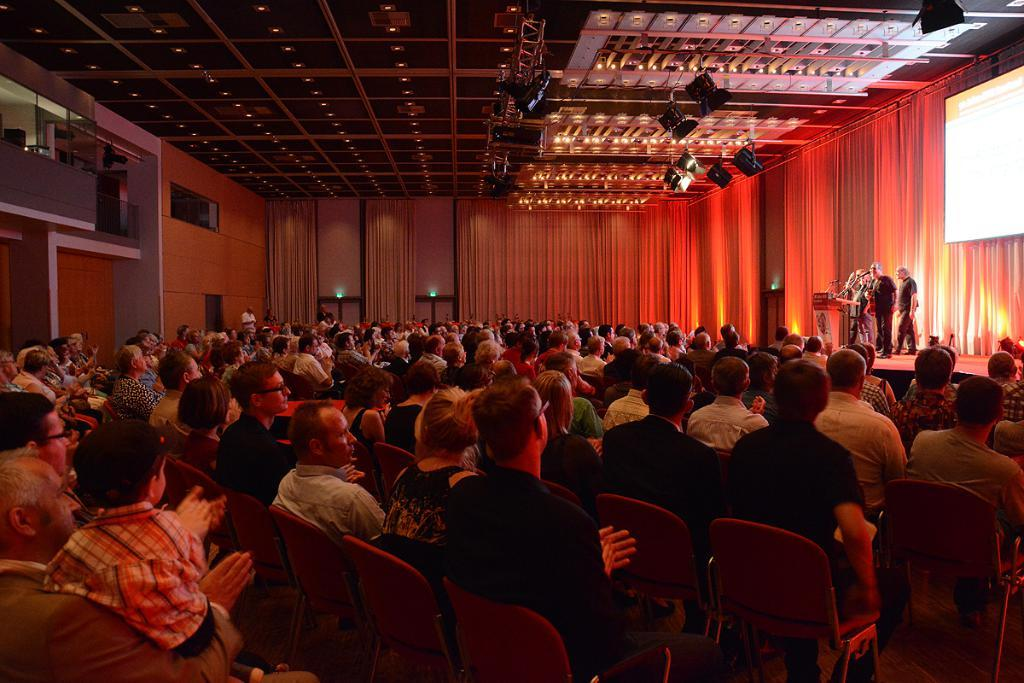What are the people in the image doing while seated on chairs? The information provided does not specify what the seated people are doing. What is the location of the people standing on the dais? The people standing on the dais are in the image. What are the people on the dais using to address the audience? The people on the dais are speaking at a podium. What is the purpose of the projector screen on the wall? The purpose of the projector screen is not specified in the provided facts. Can you see any rifles being used by the people in the image? There is no mention of rifles in the provided facts, and therefore no such objects can be observed in the image. Are the people in the image floating in space? There is no indication of space or floating in the provided facts, and the image does not suggest a space setting. 